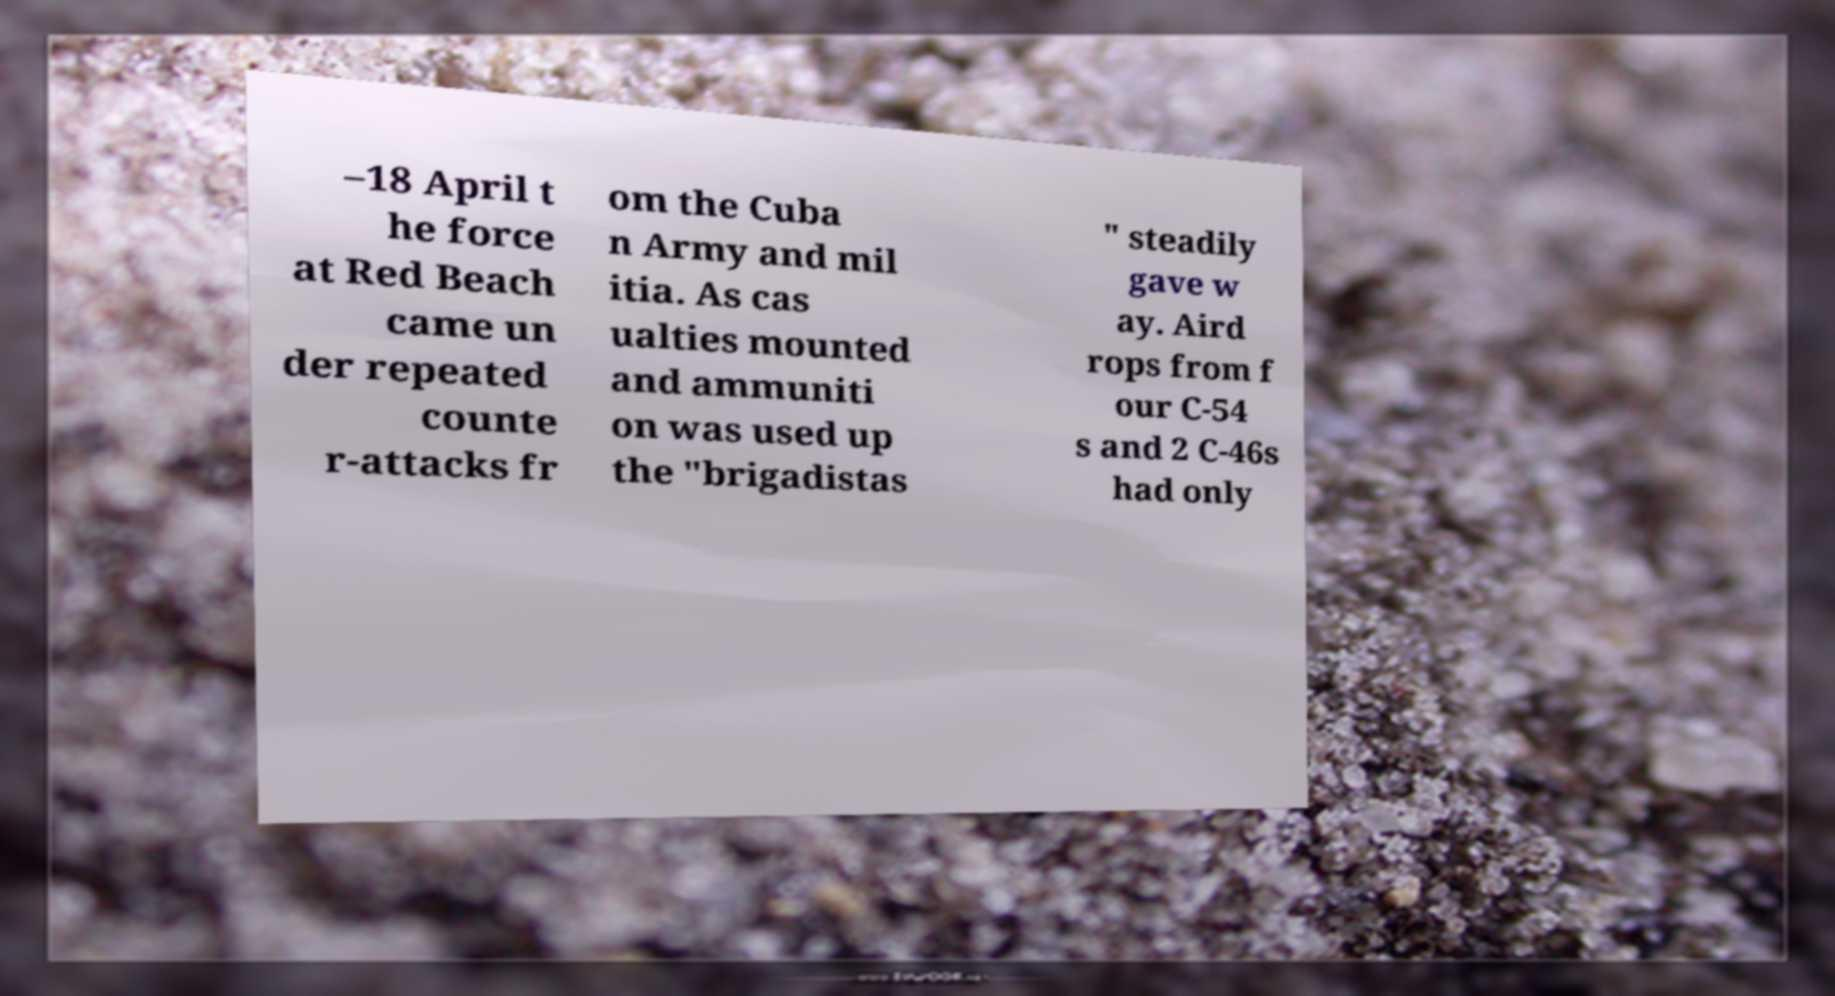Could you extract and type out the text from this image? –18 April t he force at Red Beach came un der repeated counte r-attacks fr om the Cuba n Army and mil itia. As cas ualties mounted and ammuniti on was used up the "brigadistas " steadily gave w ay. Aird rops from f our C-54 s and 2 C-46s had only 